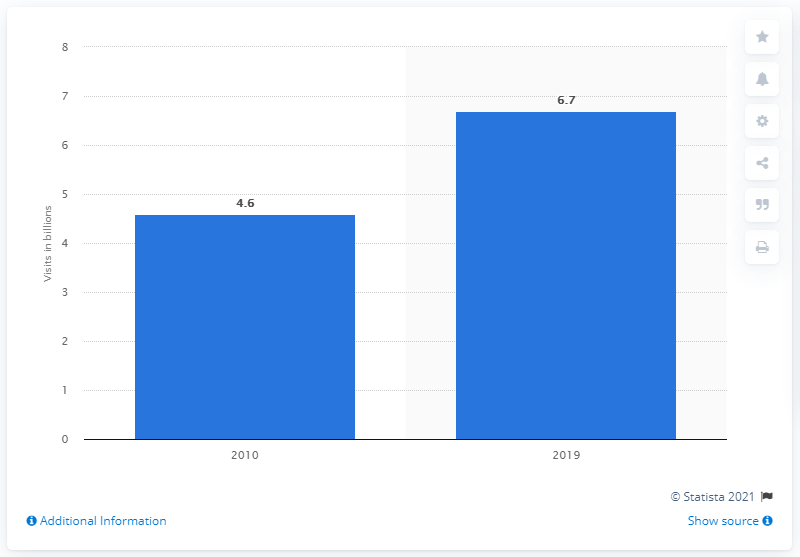List a handful of essential elements in this visual. In 2019, the total number of visits to a health club or gym in the United States was approximately 6.7 million. 